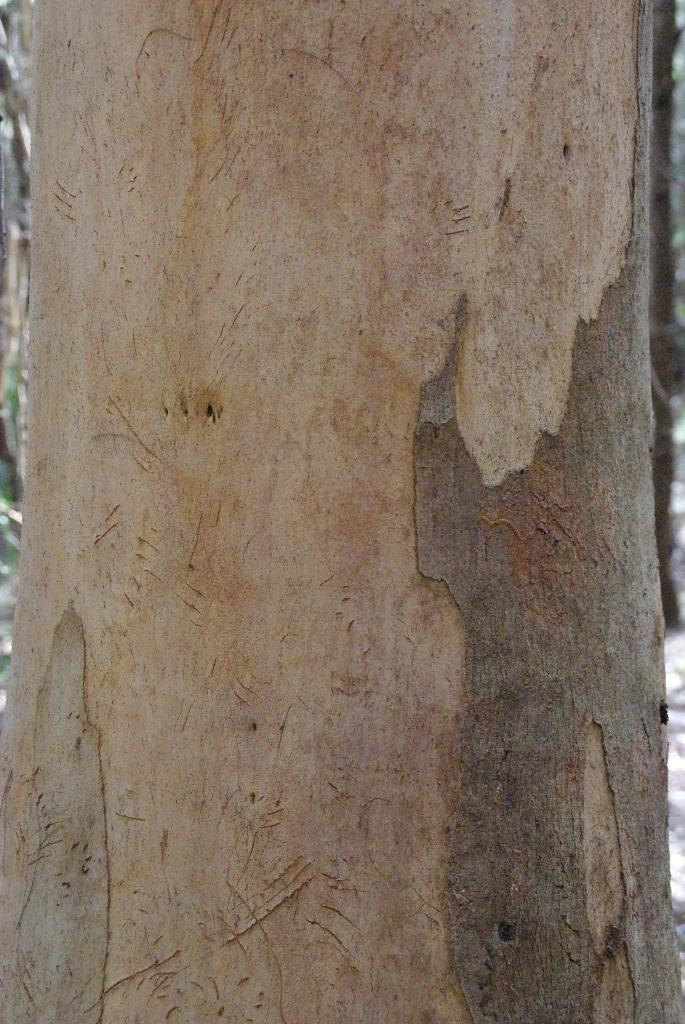What is the main subject of the image? The main subject of the image is tree bark. Can you describe the texture of the tree bark? The texture of the tree bark is rough and uneven. What type of environment might this image be associated with? The image might be associated with a natural environment, such as a forest or park. How many houses can be seen in the image? There are no houses present in the image; it only features tree bark. What type of stitch is used to create the pattern on the tree bark? The image does not depict a pattern or stitch on the tree bark; it is a natural texture. 